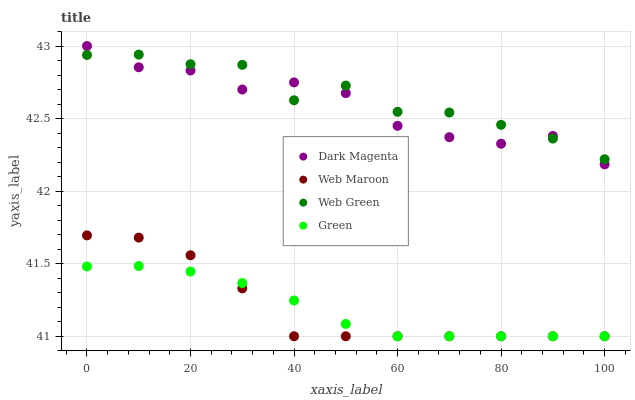Does Green have the minimum area under the curve?
Answer yes or no. Yes. Does Web Green have the maximum area under the curve?
Answer yes or no. Yes. Does Web Maroon have the minimum area under the curve?
Answer yes or no. No. Does Web Maroon have the maximum area under the curve?
Answer yes or no. No. Is Green the smoothest?
Answer yes or no. Yes. Is Web Green the roughest?
Answer yes or no. Yes. Is Web Maroon the smoothest?
Answer yes or no. No. Is Web Maroon the roughest?
Answer yes or no. No. Does Green have the lowest value?
Answer yes or no. Yes. Does Dark Magenta have the lowest value?
Answer yes or no. No. Does Dark Magenta have the highest value?
Answer yes or no. Yes. Does Web Maroon have the highest value?
Answer yes or no. No. Is Web Maroon less than Dark Magenta?
Answer yes or no. Yes. Is Web Green greater than Green?
Answer yes or no. Yes. Does Dark Magenta intersect Web Green?
Answer yes or no. Yes. Is Dark Magenta less than Web Green?
Answer yes or no. No. Is Dark Magenta greater than Web Green?
Answer yes or no. No. Does Web Maroon intersect Dark Magenta?
Answer yes or no. No. 